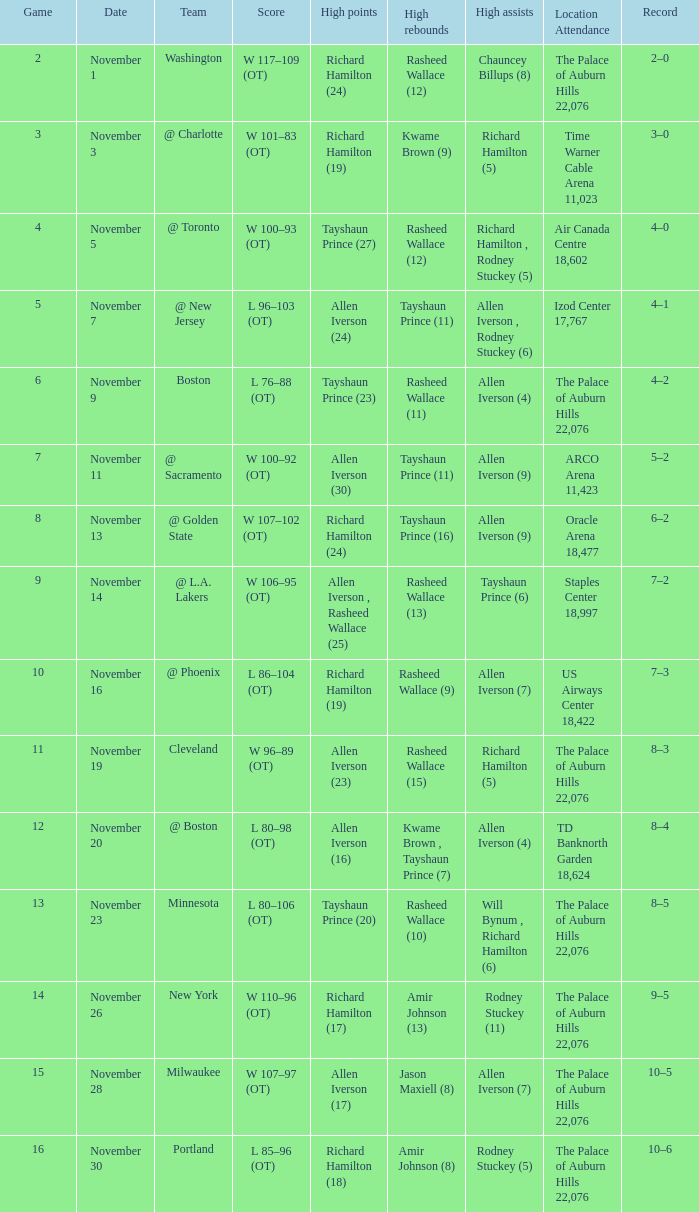What is the average Game, when Team is "Milwaukee"? 15.0. 